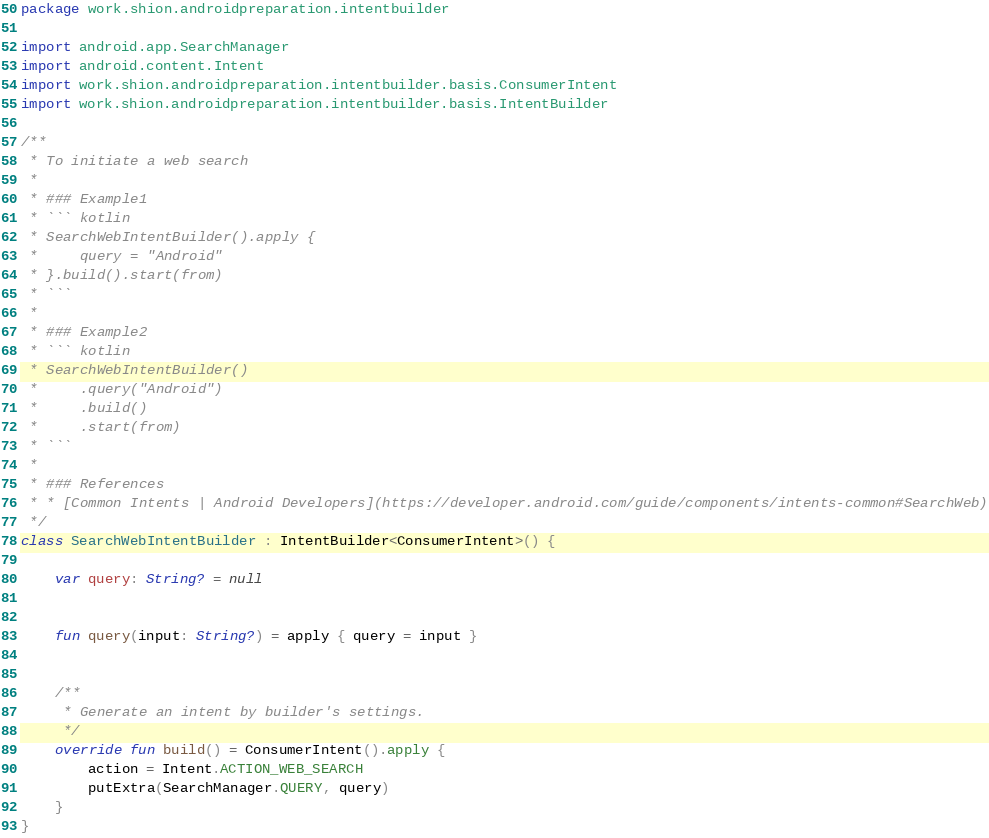<code> <loc_0><loc_0><loc_500><loc_500><_Kotlin_>package work.shion.androidpreparation.intentbuilder

import android.app.SearchManager
import android.content.Intent
import work.shion.androidpreparation.intentbuilder.basis.ConsumerIntent
import work.shion.androidpreparation.intentbuilder.basis.IntentBuilder

/**
 * To initiate a web search
 *
 * ### Example1
 * ``` kotlin
 * SearchWebIntentBuilder().apply {
 *     query = "Android"
 * }.build().start(from)
 * ```
 *
 * ### Example2
 * ``` kotlin
 * SearchWebIntentBuilder()
 *     .query("Android")
 *     .build()
 *     .start(from)
 * ```
 *
 * ### References
 * * [Common Intents | Android Developers](https://developer.android.com/guide/components/intents-common#SearchWeb)
 */
class SearchWebIntentBuilder : IntentBuilder<ConsumerIntent>() {

    var query: String? = null


    fun query(input: String?) = apply { query = input }


    /**
     * Generate an intent by builder's settings.
     */
    override fun build() = ConsumerIntent().apply {
        action = Intent.ACTION_WEB_SEARCH
        putExtra(SearchManager.QUERY, query)
    }
}
</code> 